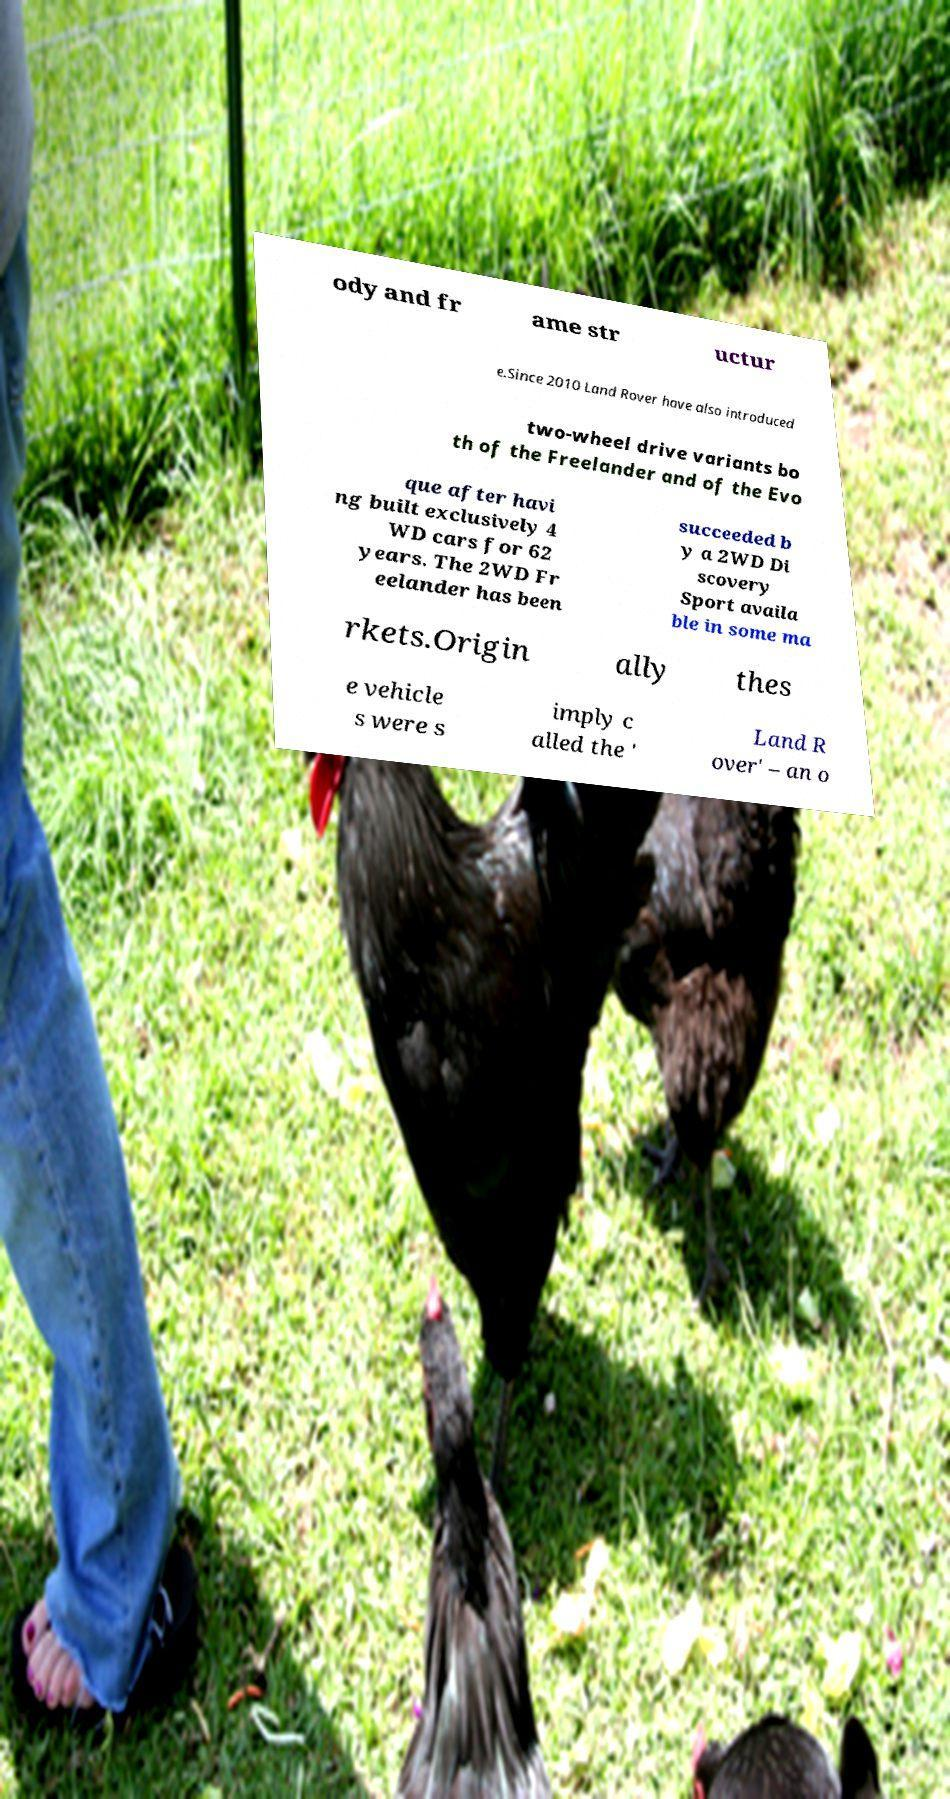Please identify and transcribe the text found in this image. ody and fr ame str uctur e.Since 2010 Land Rover have also introduced two-wheel drive variants bo th of the Freelander and of the Evo que after havi ng built exclusively 4 WD cars for 62 years. The 2WD Fr eelander has been succeeded b y a 2WD Di scovery Sport availa ble in some ma rkets.Origin ally thes e vehicle s were s imply c alled the ' Land R over' – an o 